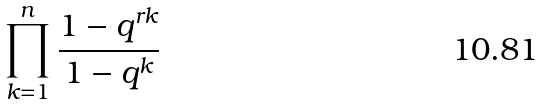<formula> <loc_0><loc_0><loc_500><loc_500>\prod _ { k = 1 } ^ { n } \frac { 1 - q ^ { r k } } { 1 - q ^ { k } }</formula> 